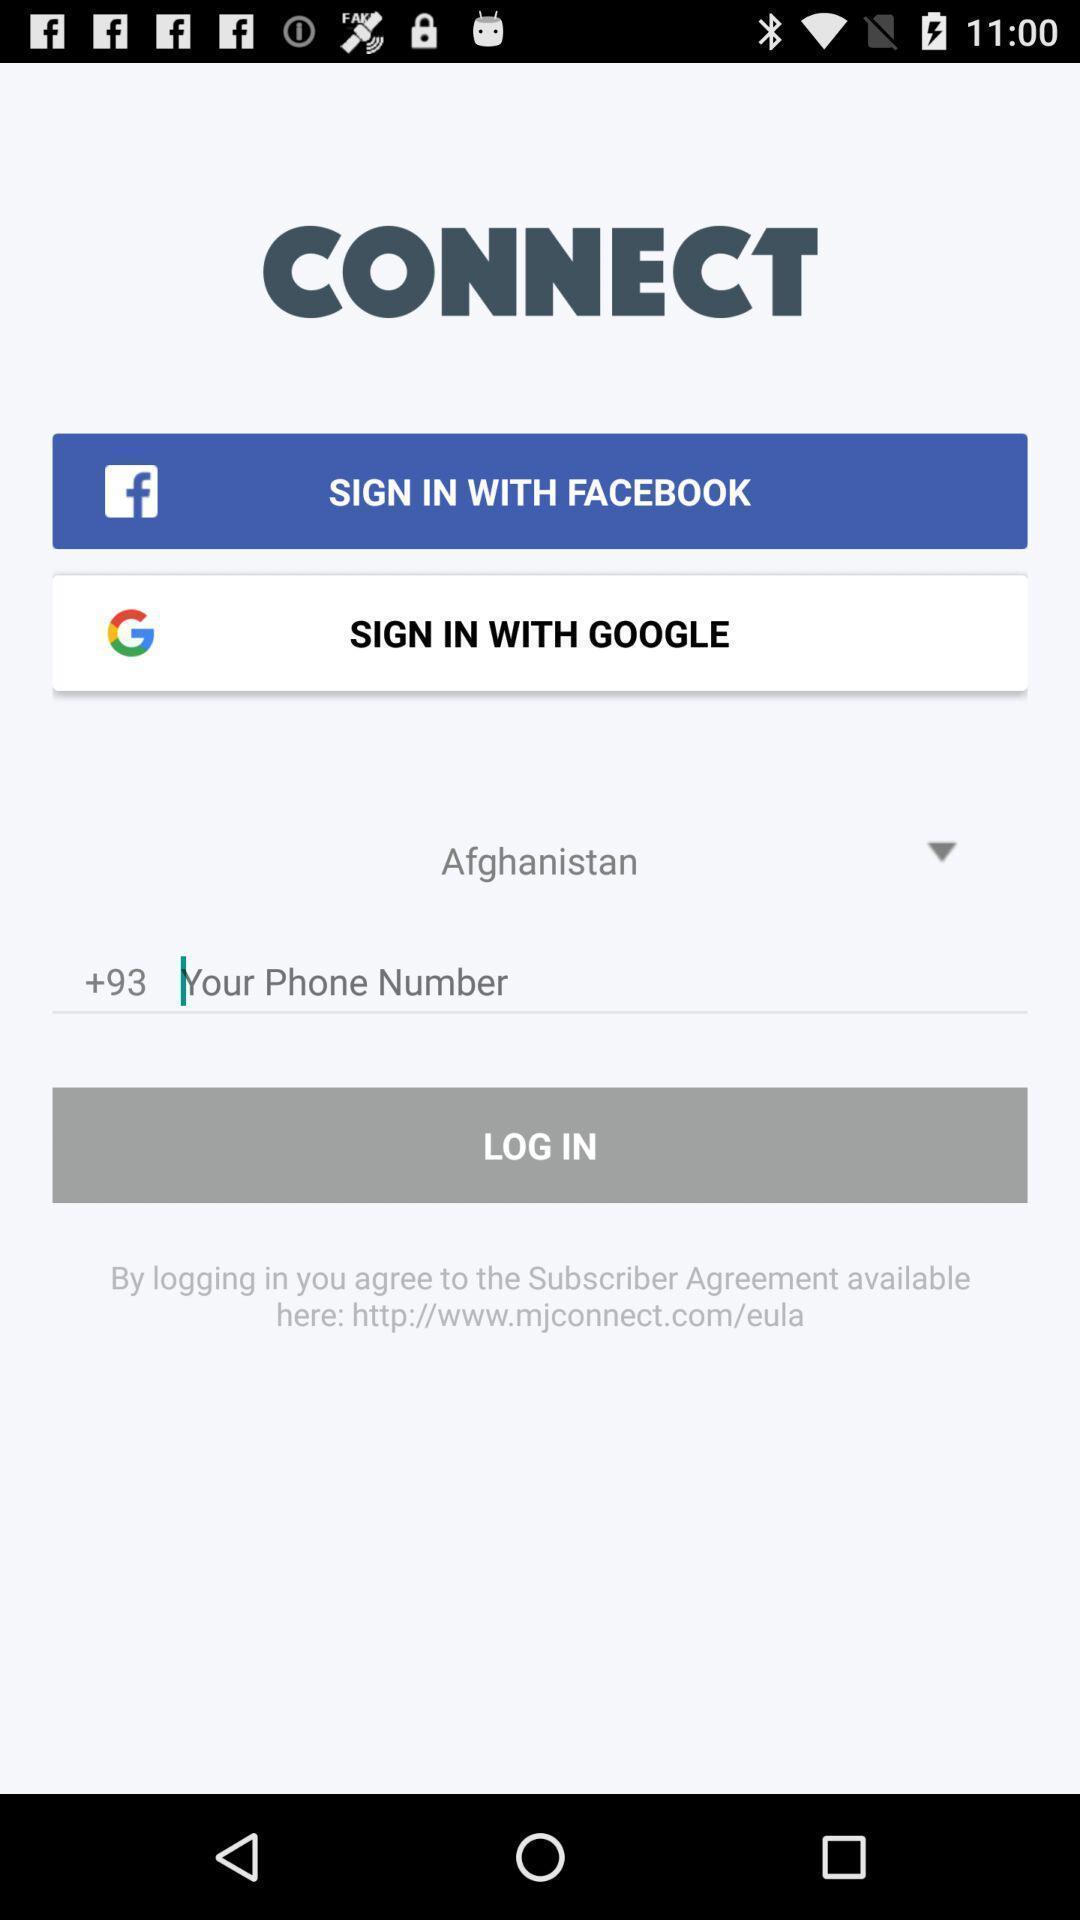What can you discern from this picture? Page showing different sign-in options. 